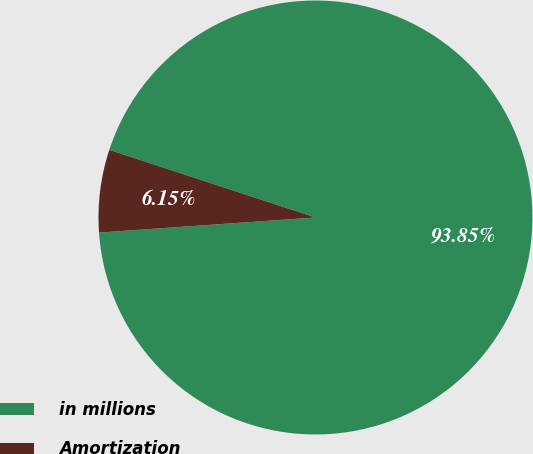<chart> <loc_0><loc_0><loc_500><loc_500><pie_chart><fcel>in millions<fcel>Amortization<nl><fcel>93.85%<fcel>6.15%<nl></chart> 